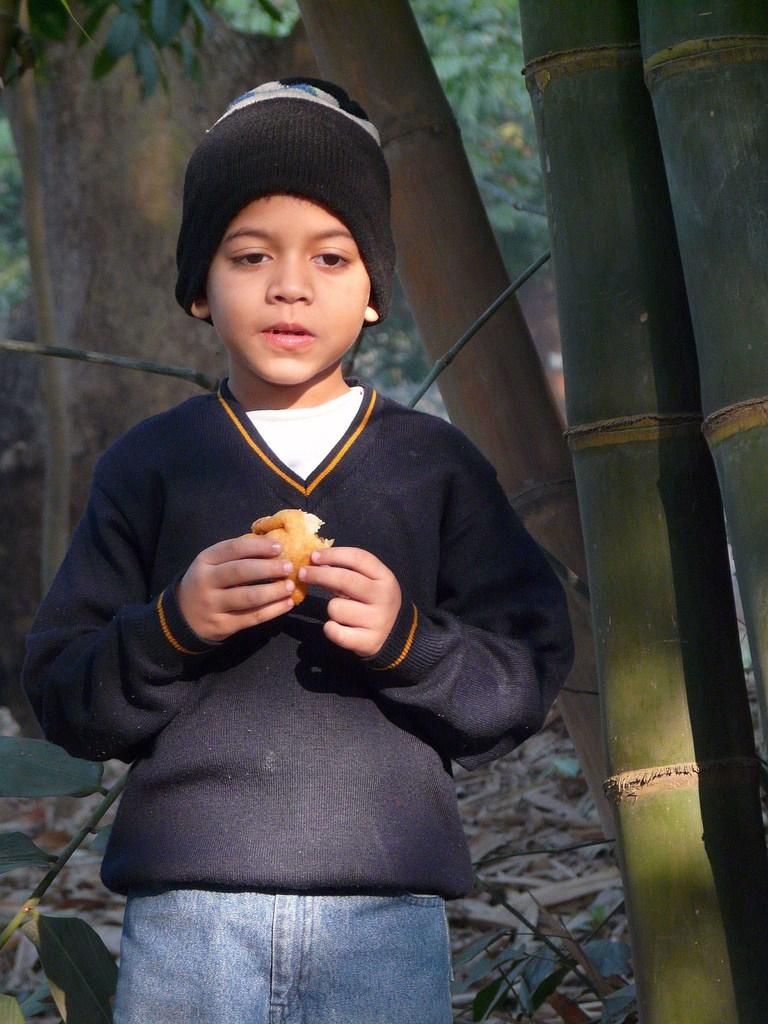Who is the main subject in the image? There is a boy in the image. What is the boy holding in his hand? The boy is holding a food item in his hand. What can be seen in the background of the image? There are trees visible in the background of the image. What type of natural debris is present on the surface at the bottom of the image? Dried leaves are present on the surface at the bottom of the image. What language is the boy speaking in the image? The image does not provide any information about the language being spoken by the boy. Can you describe the boy's grandmother in the image? There is no grandmother present in the image; it only features the boy and the food item he is holding. 